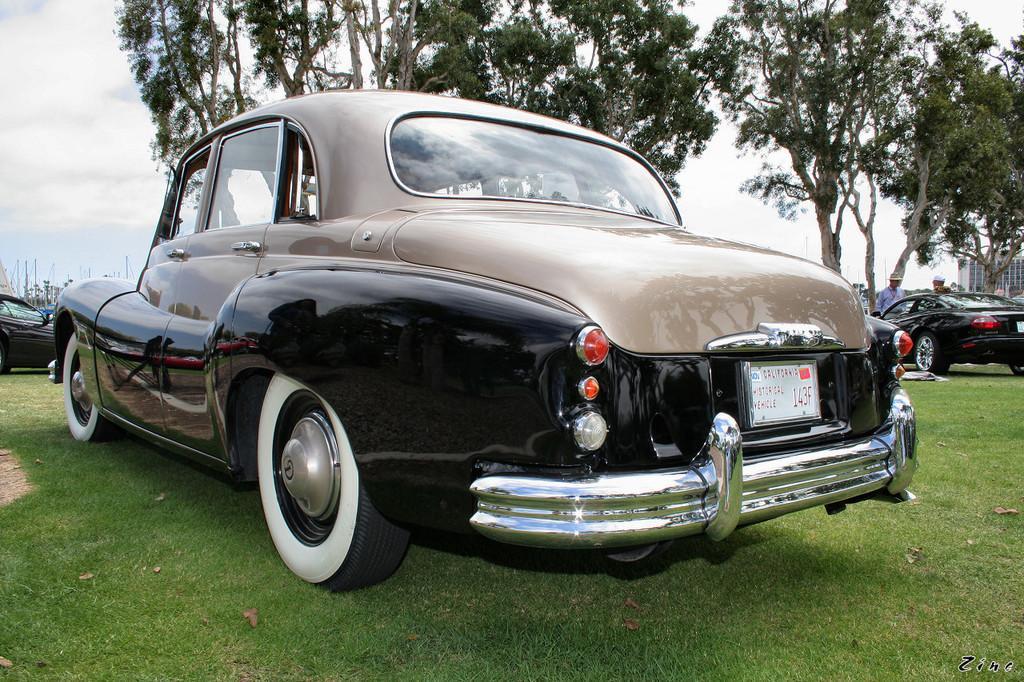In one or two sentences, can you explain what this image depicts? In the image we can see there are cars which are parked on the ground and the ground is covered with grass. Behind there are people standing, there is a building and there are lot of trees. 